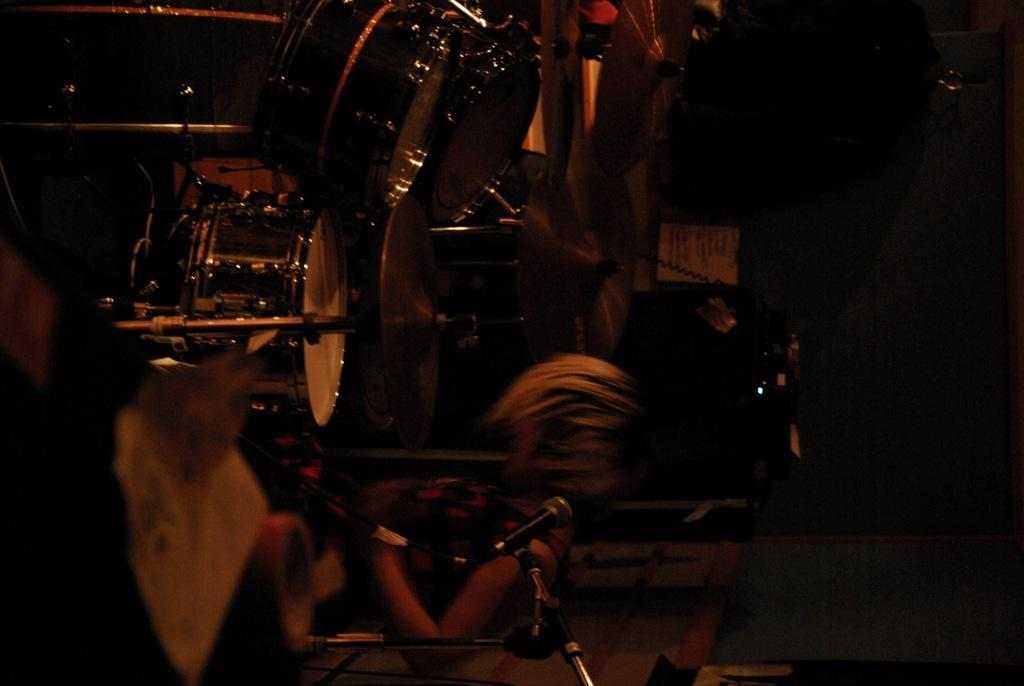What is the main subject of the image? There is a person in the image. What is the person doing in the image? The person is standing and playing a drum set. What additional features are present on the drum set? There are cymbals attached to the drum set. What type of loaf is the person holding while playing the drum set? There is no loaf present in the image; the person is playing a drum set with cymbals attached. What role does the minister play in the image? There is no minister present in the image; it features a person playing a drum set. 